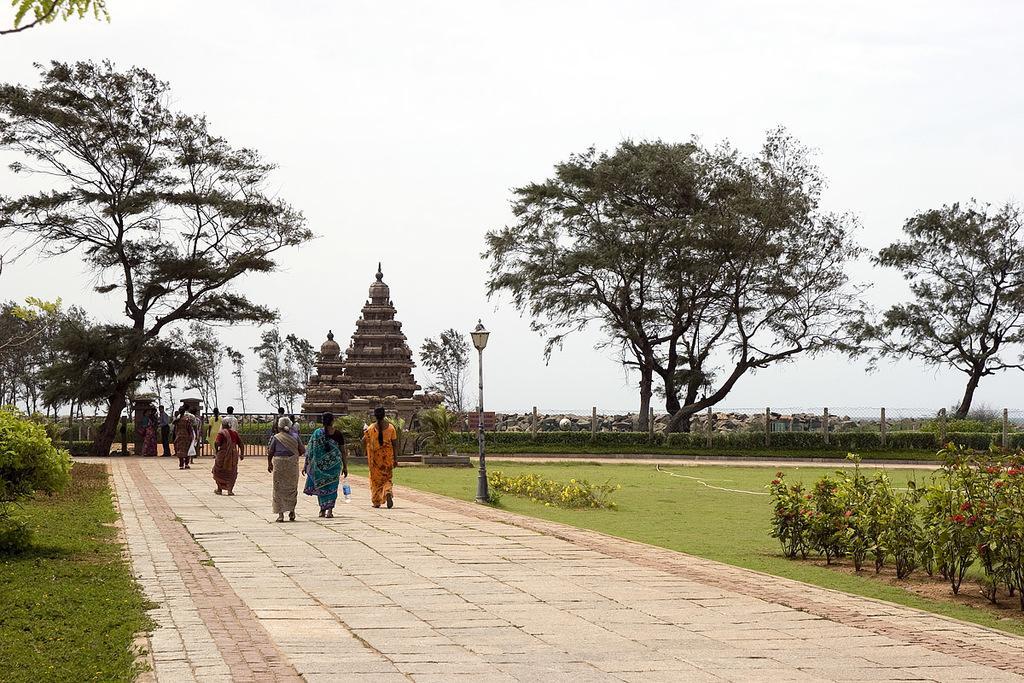Describe this image in one or two sentences. In this image there is a path, on that path people are walking and there is garden, in the background there is a temple and there are trees and a sky. 